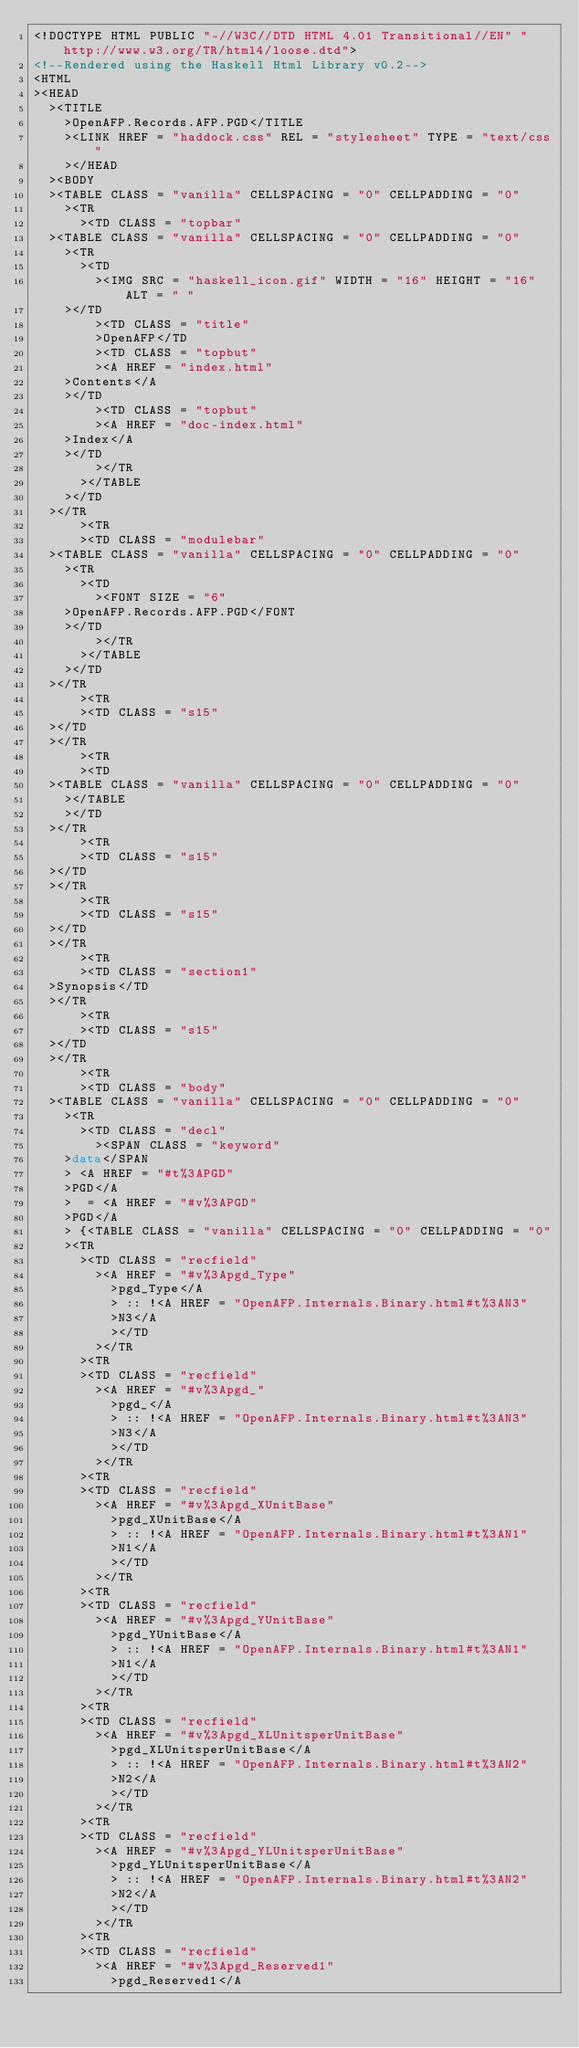<code> <loc_0><loc_0><loc_500><loc_500><_HTML_><!DOCTYPE HTML PUBLIC "-//W3C//DTD HTML 4.01 Transitional//EN" "http://www.w3.org/TR/html4/loose.dtd">
<!--Rendered using the Haskell Html Library v0.2-->
<HTML
><HEAD
  ><TITLE
    >OpenAFP.Records.AFP.PGD</TITLE
    ><LINK HREF = "haddock.css" REL = "stylesheet" TYPE = "text/css"
    ></HEAD
  ><BODY
  ><TABLE CLASS = "vanilla" CELLSPACING = "0" CELLPADDING = "0"
    ><TR
      ><TD CLASS = "topbar"
	><TABLE CLASS = "vanilla" CELLSPACING = "0" CELLPADDING = "0"
	  ><TR
	    ><TD
	      ><IMG SRC = "haskell_icon.gif" WIDTH = "16" HEIGHT = "16" ALT = " "
		></TD
	      ><TD CLASS = "title"
	      >OpenAFP</TD
	      ><TD CLASS = "topbut"
	      ><A HREF = "index.html"
		>Contents</A
		></TD
	      ><TD CLASS = "topbut"
	      ><A HREF = "doc-index.html"
		>Index</A
		></TD
	      ></TR
	    ></TABLE
	  ></TD
	></TR
      ><TR
      ><TD CLASS = "modulebar"
	><TABLE CLASS = "vanilla" CELLSPACING = "0" CELLPADDING = "0"
	  ><TR
	    ><TD
	      ><FONT SIZE = "6"
		>OpenAFP.Records.AFP.PGD</FONT
		></TD
	      ></TR
	    ></TABLE
	  ></TD
	></TR
      ><TR
      ><TD CLASS = "s15"
	></TD
	></TR
      ><TR
      ><TD
	><TABLE CLASS = "vanilla" CELLSPACING = "0" CELLPADDING = "0"
	  ></TABLE
	  ></TD
	></TR
      ><TR
      ><TD CLASS = "s15"
	></TD
	></TR
      ><TR
      ><TD CLASS = "s15"
	></TD
	></TR
      ><TR
      ><TD CLASS = "section1"
	>Synopsis</TD
	></TR
      ><TR
      ><TD CLASS = "s15"
	></TD
	></TR
      ><TR
      ><TD CLASS = "body"
	><TABLE CLASS = "vanilla" CELLSPACING = "0" CELLPADDING = "0"
	  ><TR
	    ><TD CLASS = "decl"
	      ><SPAN CLASS = "keyword"
		>data</SPAN
		> <A HREF = "#t%3APGD"
		>PGD</A
		>  = <A HREF = "#v%3APGD"
		>PGD</A
		> {<TABLE CLASS = "vanilla" CELLSPACING = "0" CELLPADDING = "0"
		><TR
		  ><TD CLASS = "recfield"
		    ><A HREF = "#v%3Apgd_Type"
		      >pgd_Type</A
		      > :: !<A HREF = "OpenAFP.Internals.Binary.html#t%3AN3"
		      >N3</A
		      ></TD
		    ></TR
		  ><TR
		  ><TD CLASS = "recfield"
		    ><A HREF = "#v%3Apgd_"
		      >pgd_</A
		      > :: !<A HREF = "OpenAFP.Internals.Binary.html#t%3AN3"
		      >N3</A
		      ></TD
		    ></TR
		  ><TR
		  ><TD CLASS = "recfield"
		    ><A HREF = "#v%3Apgd_XUnitBase"
		      >pgd_XUnitBase</A
		      > :: !<A HREF = "OpenAFP.Internals.Binary.html#t%3AN1"
		      >N1</A
		      ></TD
		    ></TR
		  ><TR
		  ><TD CLASS = "recfield"
		    ><A HREF = "#v%3Apgd_YUnitBase"
		      >pgd_YUnitBase</A
		      > :: !<A HREF = "OpenAFP.Internals.Binary.html#t%3AN1"
		      >N1</A
		      ></TD
		    ></TR
		  ><TR
		  ><TD CLASS = "recfield"
		    ><A HREF = "#v%3Apgd_XLUnitsperUnitBase"
		      >pgd_XLUnitsperUnitBase</A
		      > :: !<A HREF = "OpenAFP.Internals.Binary.html#t%3AN2"
		      >N2</A
		      ></TD
		    ></TR
		  ><TR
		  ><TD CLASS = "recfield"
		    ><A HREF = "#v%3Apgd_YLUnitsperUnitBase"
		      >pgd_YLUnitsperUnitBase</A
		      > :: !<A HREF = "OpenAFP.Internals.Binary.html#t%3AN2"
		      >N2</A
		      ></TD
		    ></TR
		  ><TR
		  ><TD CLASS = "recfield"
		    ><A HREF = "#v%3Apgd_Reserved1"
		      >pgd_Reserved1</A</code> 